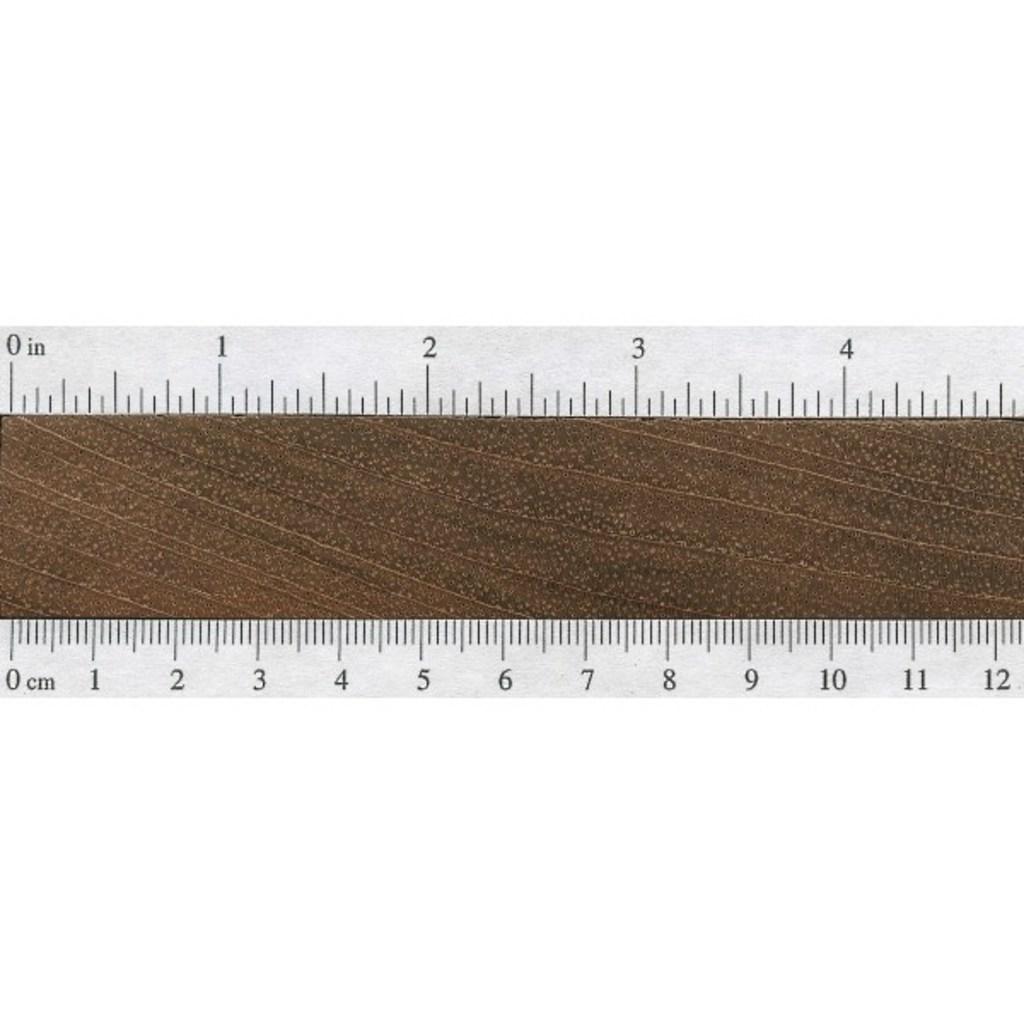How long is the ruler?
Keep it short and to the point. 12 cm. What length is the bottom in?
Make the answer very short. Cm. 